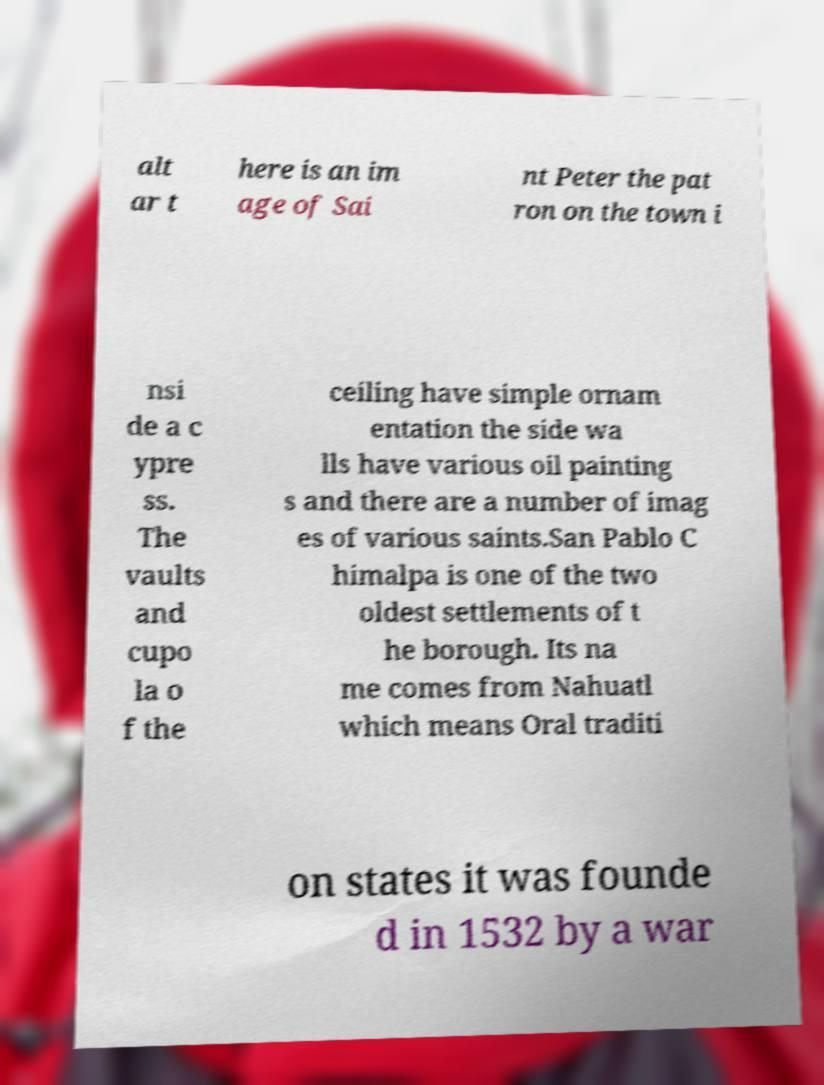What messages or text are displayed in this image? I need them in a readable, typed format. alt ar t here is an im age of Sai nt Peter the pat ron on the town i nsi de a c ypre ss. The vaults and cupo la o f the ceiling have simple ornam entation the side wa lls have various oil painting s and there are a number of imag es of various saints.San Pablo C himalpa is one of the two oldest settlements of t he borough. Its na me comes from Nahuatl which means Oral traditi on states it was founde d in 1532 by a war 